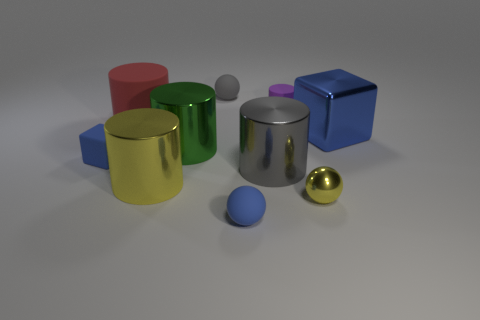Subtract all large cylinders. How many cylinders are left? 1 Subtract all gray balls. How many balls are left? 2 Subtract all spheres. How many objects are left? 7 Subtract 1 cylinders. How many cylinders are left? 4 Subtract all cyan cylinders. Subtract all purple blocks. How many cylinders are left? 5 Subtract all small cylinders. Subtract all tiny cubes. How many objects are left? 8 Add 7 blue spheres. How many blue spheres are left? 8 Add 8 big green metal cylinders. How many big green metal cylinders exist? 9 Subtract 0 yellow cubes. How many objects are left? 10 